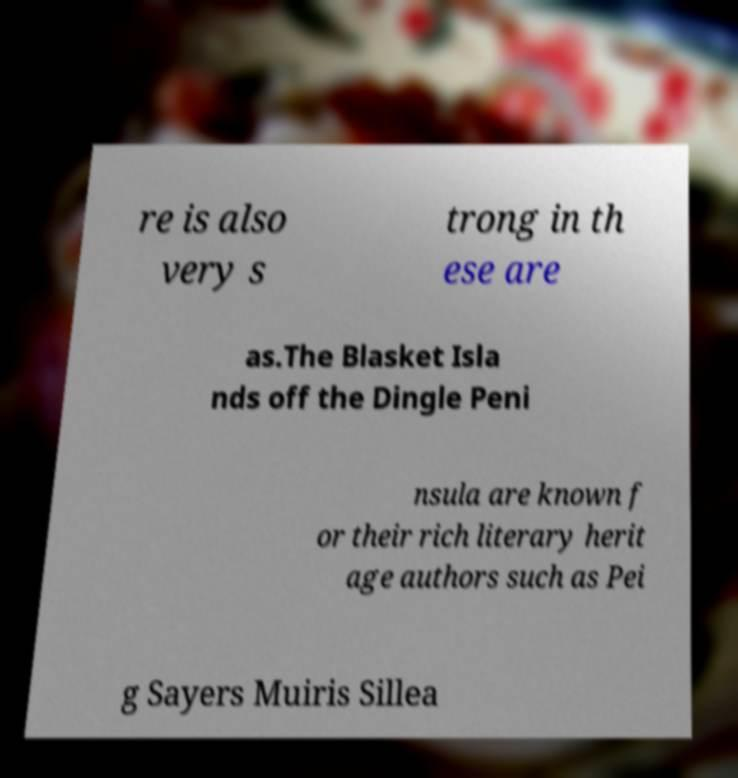Can you read and provide the text displayed in the image?This photo seems to have some interesting text. Can you extract and type it out for me? re is also very s trong in th ese are as.The Blasket Isla nds off the Dingle Peni nsula are known f or their rich literary herit age authors such as Pei g Sayers Muiris Sillea 